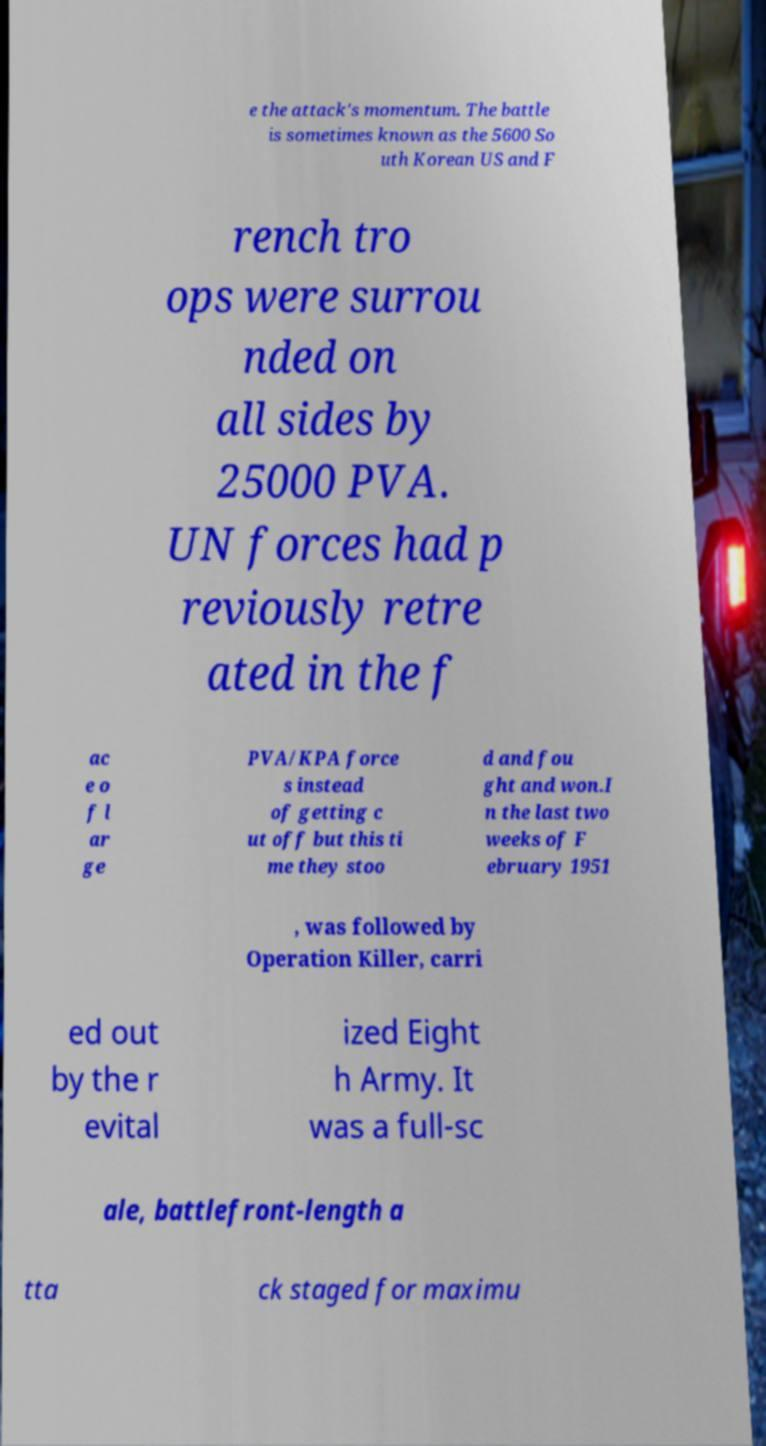Please identify and transcribe the text found in this image. e the attack's momentum. The battle is sometimes known as the 5600 So uth Korean US and F rench tro ops were surrou nded on all sides by 25000 PVA. UN forces had p reviously retre ated in the f ac e o f l ar ge PVA/KPA force s instead of getting c ut off but this ti me they stoo d and fou ght and won.I n the last two weeks of F ebruary 1951 , was followed by Operation Killer, carri ed out by the r evital ized Eight h Army. It was a full-sc ale, battlefront-length a tta ck staged for maximu 